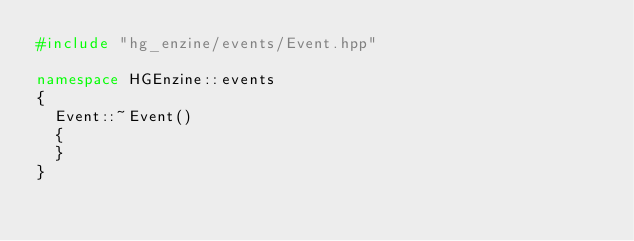<code> <loc_0><loc_0><loc_500><loc_500><_C++_>#include "hg_enzine/events/Event.hpp"

namespace HGEnzine::events
{
  Event::~Event()
  {
  }
}

</code> 